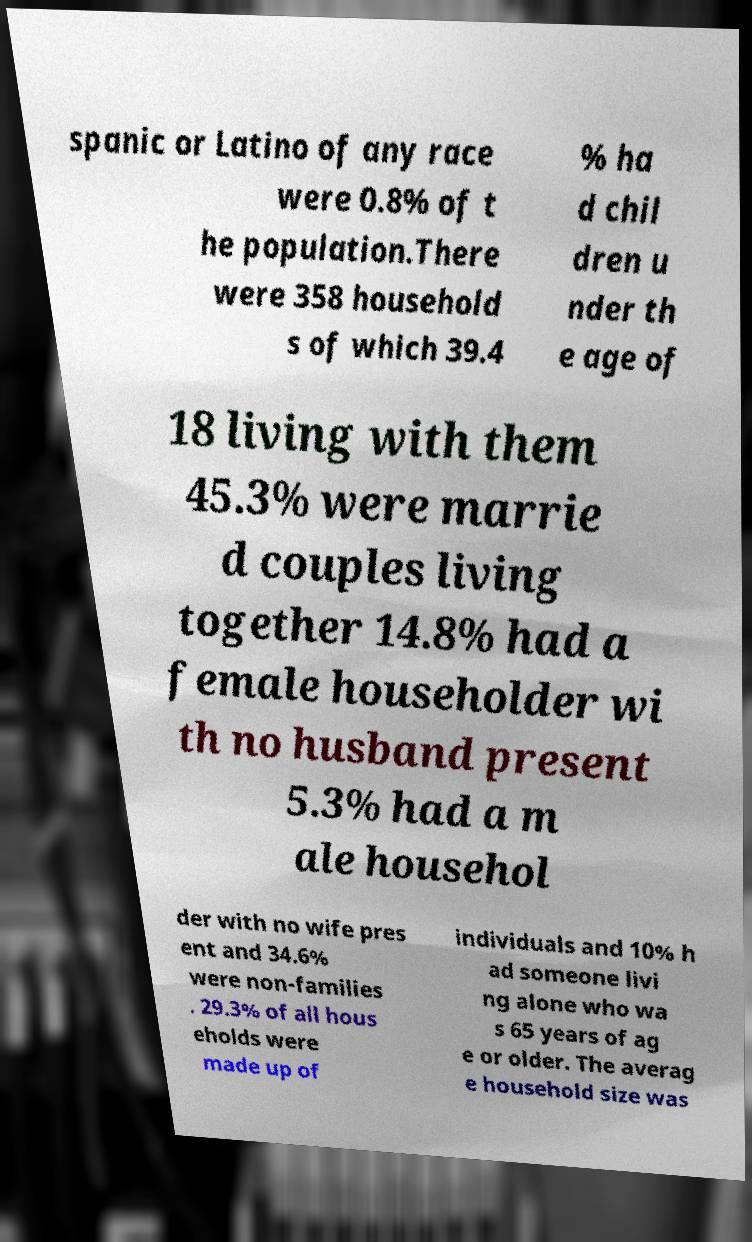Can you accurately transcribe the text from the provided image for me? spanic or Latino of any race were 0.8% of t he population.There were 358 household s of which 39.4 % ha d chil dren u nder th e age of 18 living with them 45.3% were marrie d couples living together 14.8% had a female householder wi th no husband present 5.3% had a m ale househol der with no wife pres ent and 34.6% were non-families . 29.3% of all hous eholds were made up of individuals and 10% h ad someone livi ng alone who wa s 65 years of ag e or older. The averag e household size was 